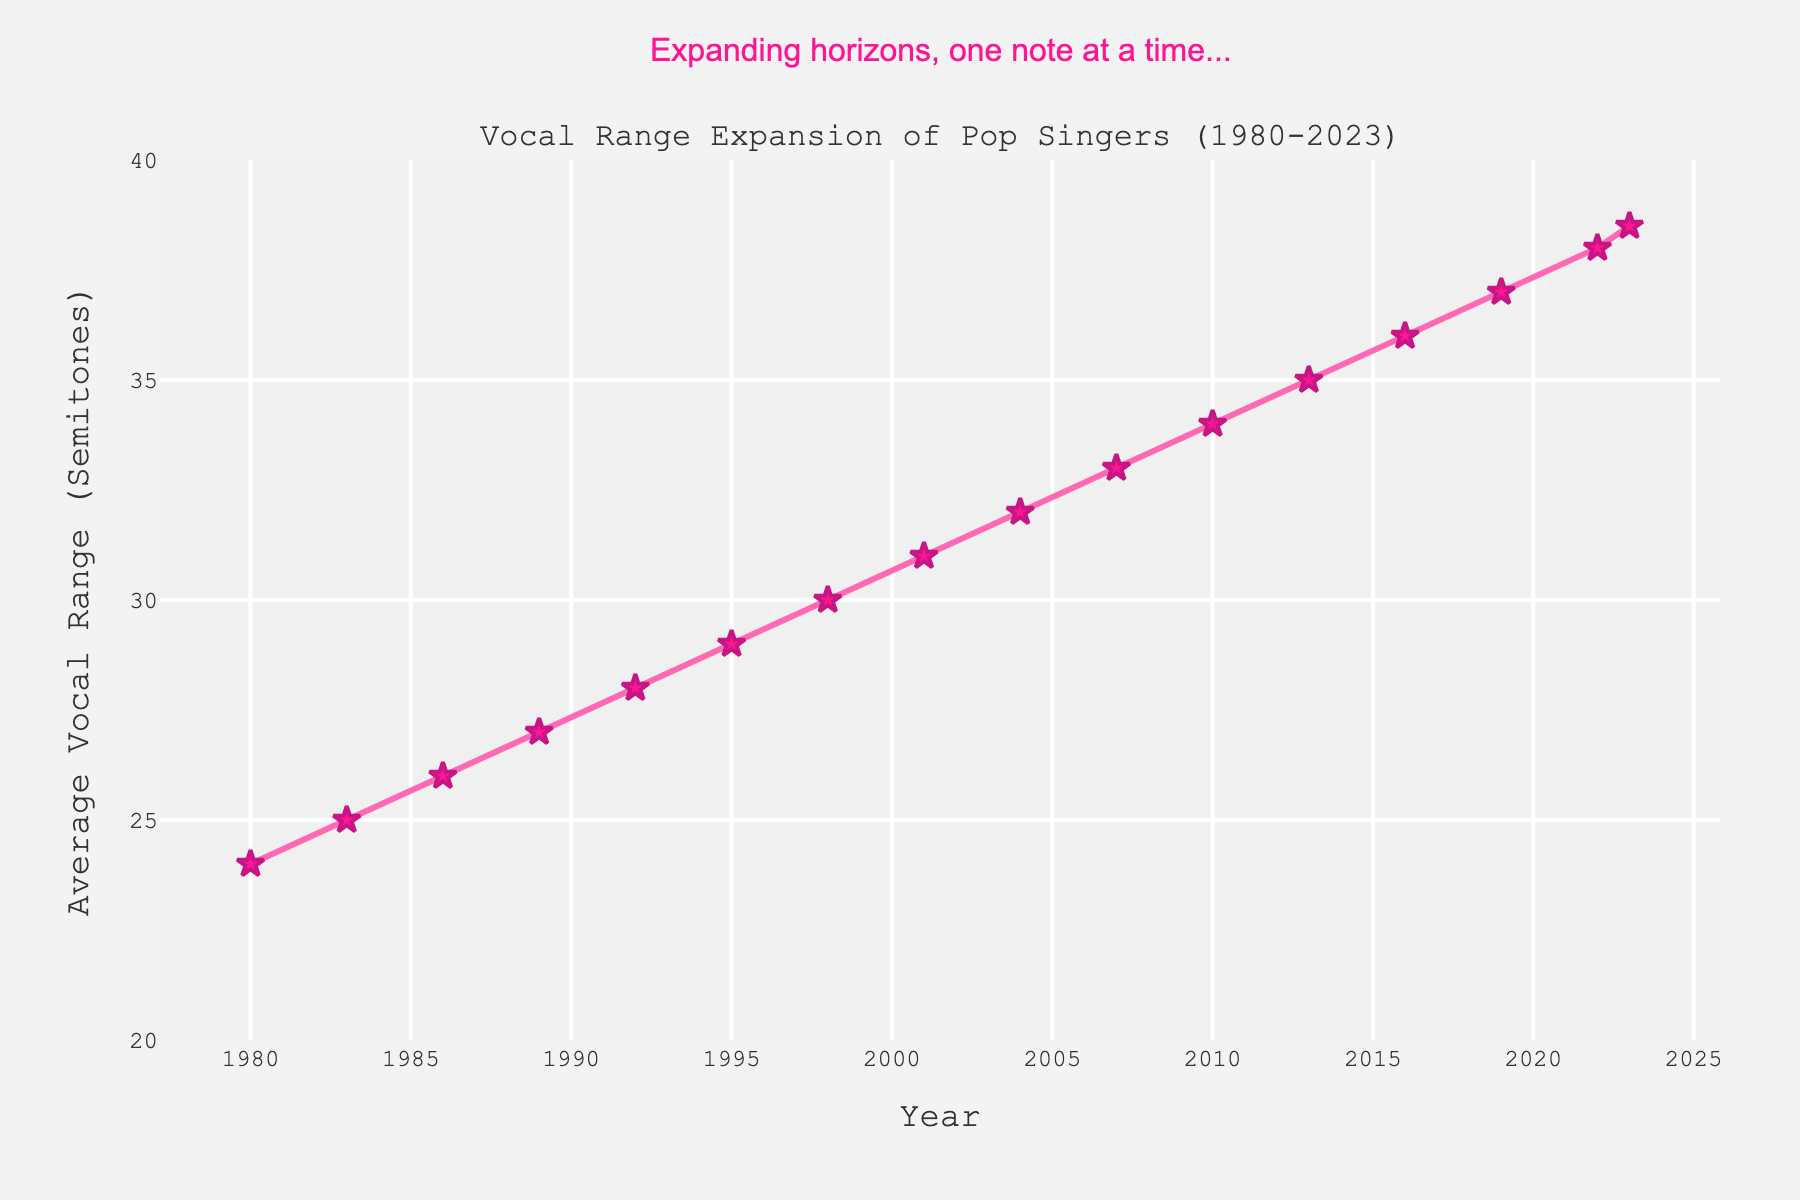what is the average vocal range in 1992? Look at the data point for the year 1992 on the x-axis and read the corresponding value on the y-axis. The average vocal range for that year is noted as 28 semitones.
Answer: 28 What was the increase in average vocal range from 1980 to 2023? To find the increase, subtract the value for the year 1980 (24 semitones) from the value for the year 2023 (38.5 semitones). Calculation: 38.5 - 24 = 14.5.
Answer: 14.5 In which period did the average vocal range increase by exactly one semitone? Look at the increments between consecutive data points and identify where the increase is exactly 1 semitone. For example, between 1983 (25 semitones) and 1986 (26 semitones) and between 2001 (31 semitones) and 2004 (32 semitones).
Answer: 1983-1986 and 2001-2004 What is the highest average vocal range recorded in the data? Identify the highest value on the y-axis. The highest recorded average vocal range is 38.5 semitones in the year 2023.
Answer: 38.5 Is the average vocal range generally increasing, decreasing, or constant over time? By observing the trend line of the data points from 1980 to 2023, we see a general upward trajectory indicating that the average vocal range is increasing over time.
Answer: Increasing What was the average vocal range in 2010 as compared to 2022? Check the values for the years 2010 and 2022. In 2010, it was 34 semitones, and in 2022, it was 38 semitones. Compare these two values.
Answer: 34 in 2010, 38 in 2022 Between which consecutive years was the largest increase in the average vocal range? Compare the increments between consecutive data points. The largest increase is between 2022 and 2023, which is 0.5 semitones (from 38 to 38.5 semitones).
Answer: 2022-2023 How many times did the average vocal range increase by 2 semitones over consecutive periods? By analyzing the increments between consecutive periods, we find that the average vocal range increased by 2 semitones from 2007 (33 semitones) to 2010 (34 semitones).
Answer: Once Does the figure show any periods where the average vocal range did not change? By examining the data, there is no year where the range stayed exactly the same; each period shows an increase.
Answer: No 